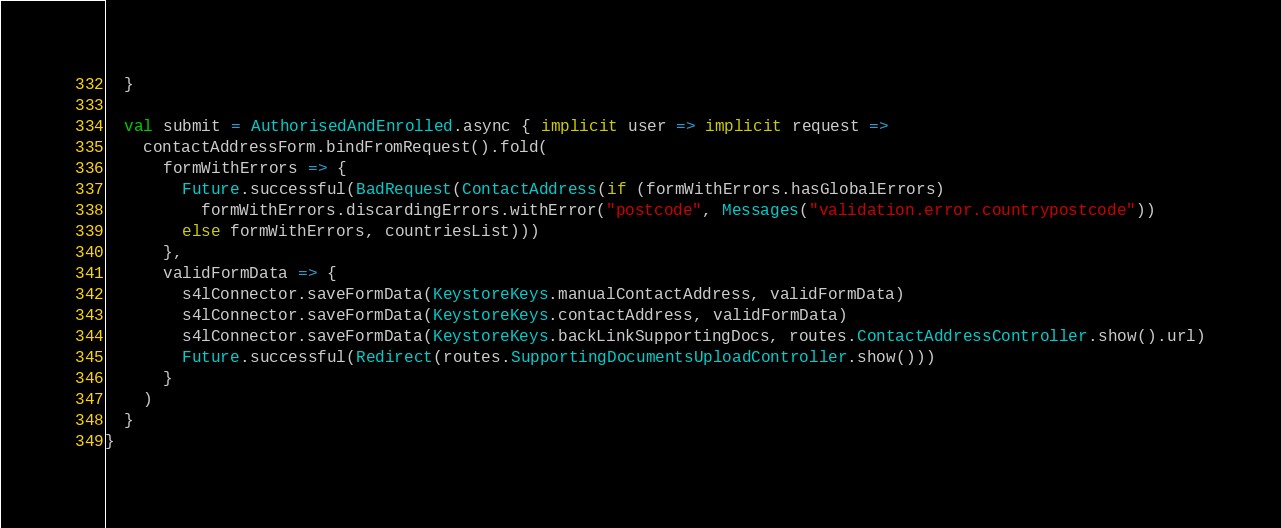Convert code to text. <code><loc_0><loc_0><loc_500><loc_500><_Scala_>  }

  val submit = AuthorisedAndEnrolled.async { implicit user => implicit request =>
    contactAddressForm.bindFromRequest().fold(
      formWithErrors => {
        Future.successful(BadRequest(ContactAddress(if (formWithErrors.hasGlobalErrors)
          formWithErrors.discardingErrors.withError("postcode", Messages("validation.error.countrypostcode"))
        else formWithErrors, countriesList)))
      },
      validFormData => {
        s4lConnector.saveFormData(KeystoreKeys.manualContactAddress, validFormData)
        s4lConnector.saveFormData(KeystoreKeys.contactAddress, validFormData)
        s4lConnector.saveFormData(KeystoreKeys.backLinkSupportingDocs, routes.ContactAddressController.show().url)
        Future.successful(Redirect(routes.SupportingDocumentsUploadController.show()))
      }
    )
  }
}
</code> 